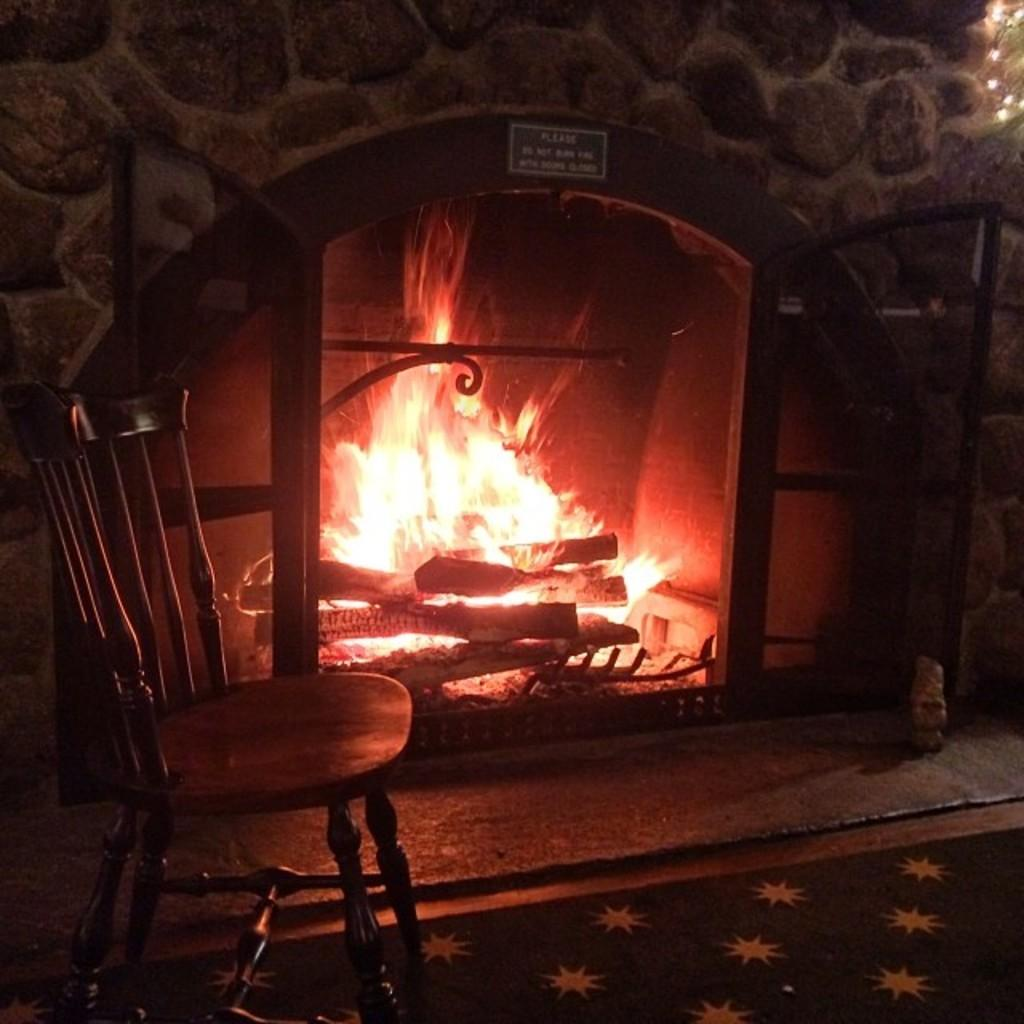What is the main feature of the image? There is a fireplace in the image. What is happening with the fireplace? Wood is burning in the fireplace. What furniture is placed near the fireplace? There is a chair in front of the fireplace. Is there anything on the floor in front of the fireplace? Yes, there is a mat in front of the fireplace. What else can be seen in the image besides the fireplace and its surroundings? There is a board with text written on it in the image. How many eggs are sitting on the suit in front of the fireplace? There is no suit or eggs present in the image. What type of gold ornament is hanging from the mantel of the fireplace? There is no gold ornament present in the image. 